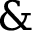<formula> <loc_0><loc_0><loc_500><loc_500>\&</formula> 